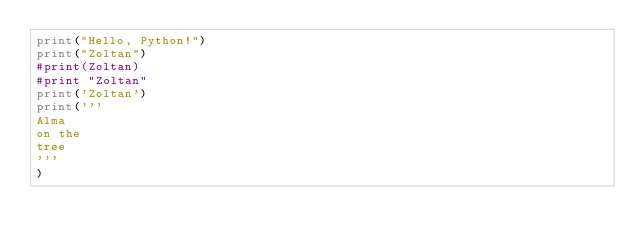<code> <loc_0><loc_0><loc_500><loc_500><_Python_>print("Hello, Python!")
print("Zoltan")
#print(Zoltan)
#print "Zoltan"
print('Zoltan')
print('''
Alma
on the
tree
'''
)
</code> 